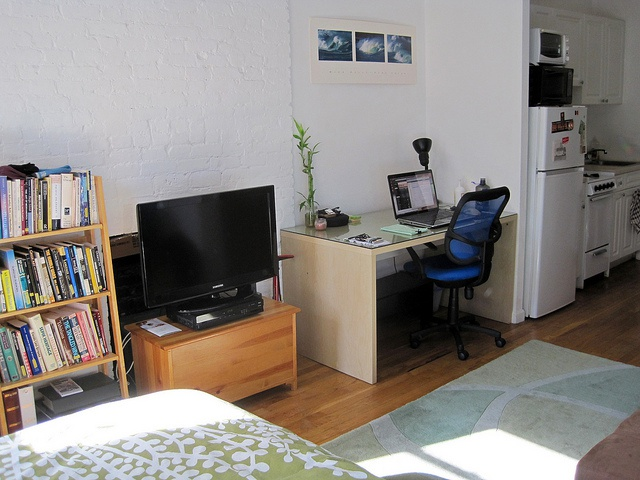Describe the objects in this image and their specific colors. I can see bed in lightgray, white, darkgray, and tan tones, book in lightgray, darkgray, gray, black, and tan tones, tv in lightgray, black, darkgray, and gray tones, refrigerator in lightgray, gray, darkgray, and black tones, and chair in lightgray, black, navy, darkblue, and gray tones in this image. 